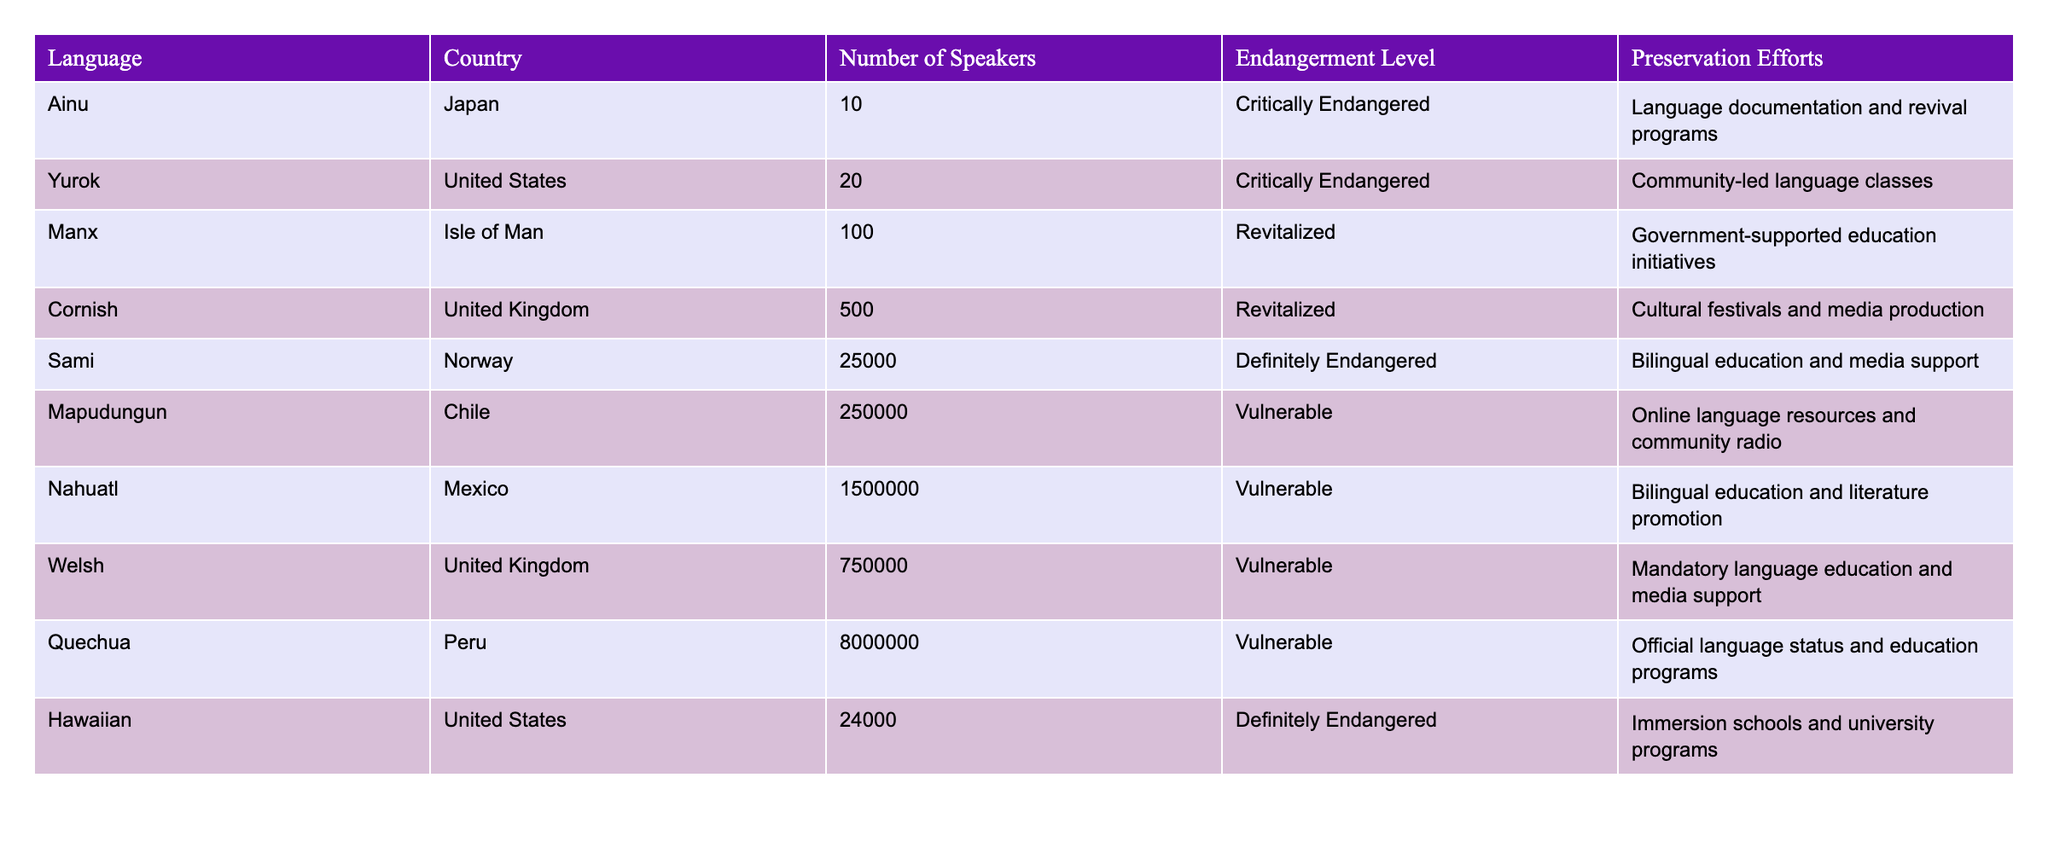What is the endangerment level of the Ainu language? The Ainu language is listed in the table under the "Endangerment Level" column, where it shows that its level is "Critically Endangered."
Answer: Critically Endangered How many speakers does the Nahuatl language have? By looking at the corresponding row in the table, Nahuatl is reported to have "1,500,000" speakers in the "Number of Speakers" column.
Answer: 1,500,000 Which language has the highest number of speakers? To determine this, we can compare the "Number of Speakers" values across the languages; Quechua has the highest at "8,000,000."
Answer: Quechua Are there more speakers of Manx than Yurok? We compare the "Number of Speakers" for both languages: Manx has "100" speakers, and Yurok has "20" speakers. Since "100" is greater than "20," the statement is true.
Answer: Yes What is the total number of speakers for all the languages listed in the table? By adding the number of speakers from each row (10 + 20 + 100 + 500 + 25,000 + 250,000 + 1,500,000 + 750,000 + 8,000,000 + 24,000), we find that the total equals 10,054,630.
Answer: 10,054,630 Which preservation effort is used for the Hawaiian language? The Hawaiian language's preservation efforts are mentioned in the respective row, where it states "Immersion schools and university programs" as the initiative.
Answer: Immersion schools and university programs Is the Cornish language considered critically endangered? Looking at the "Endangerment Level" column for Cornish, it shows "Revitalized," indicating that it is not critically endangered. Thus, the answer is no.
Answer: No What is the average number of speakers for the languages with a Vulnerable endangerment level? The languages with a Vulnerable endangerment level are Mapudungun, Nahuatl, Welsh, and Quechua. Adding their speakers (250,000 + 1,500,000 + 750,000 + 8,000,000 = 10,500,000) and dividing by the number of languages (4) gives us an average of 2,625,000 speakers.
Answer: 2,625,000 How many languages listed are classified as "Definitely Endangered"? There are two entries classified as "Definitely Endangered," which are Sami and Hawaiian, as seen in the "Endangerment Level" column.
Answer: 2 